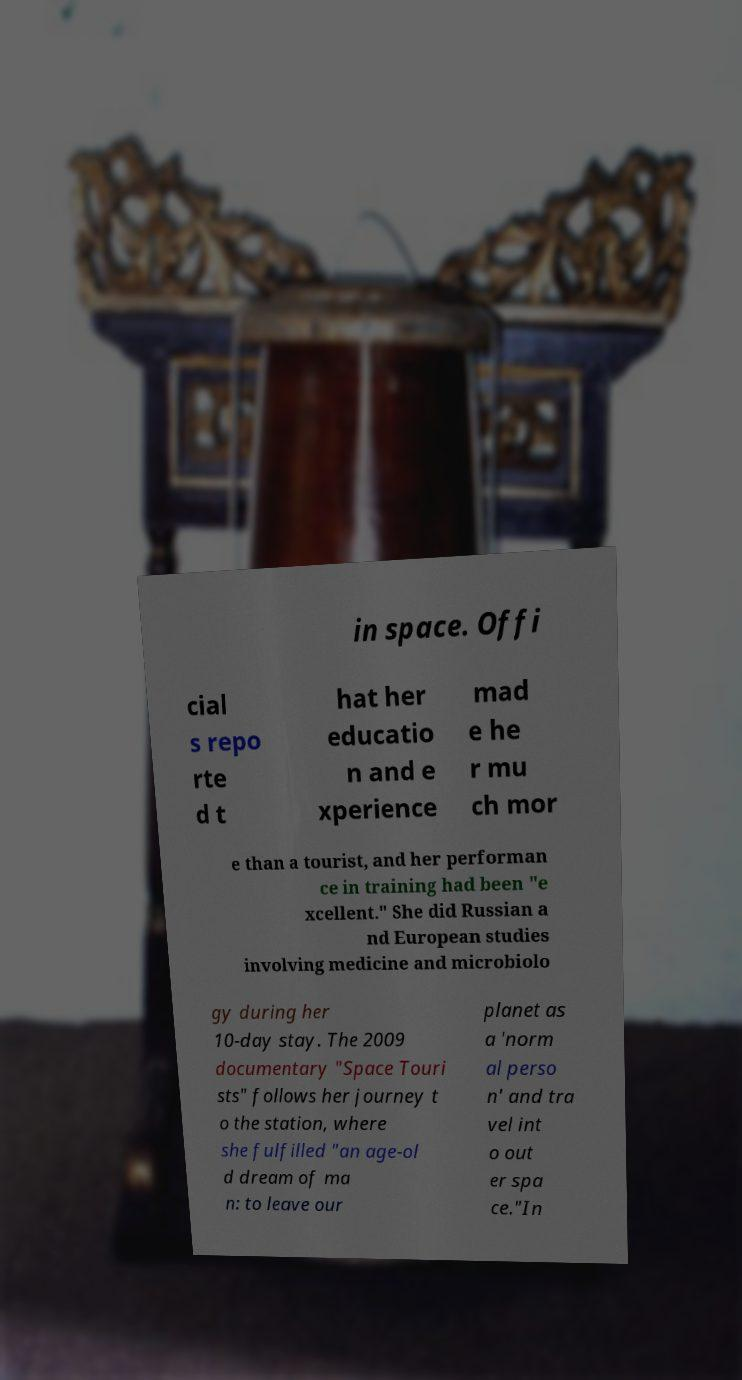Please identify and transcribe the text found in this image. in space. Offi cial s repo rte d t hat her educatio n and e xperience mad e he r mu ch mor e than a tourist, and her performan ce in training had been "e xcellent." She did Russian a nd European studies involving medicine and microbiolo gy during her 10-day stay. The 2009 documentary "Space Touri sts" follows her journey t o the station, where she fulfilled "an age-ol d dream of ma n: to leave our planet as a 'norm al perso n' and tra vel int o out er spa ce."In 